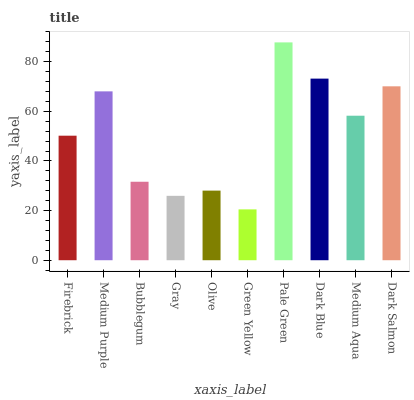Is Green Yellow the minimum?
Answer yes or no. Yes. Is Pale Green the maximum?
Answer yes or no. Yes. Is Medium Purple the minimum?
Answer yes or no. No. Is Medium Purple the maximum?
Answer yes or no. No. Is Medium Purple greater than Firebrick?
Answer yes or no. Yes. Is Firebrick less than Medium Purple?
Answer yes or no. Yes. Is Firebrick greater than Medium Purple?
Answer yes or no. No. Is Medium Purple less than Firebrick?
Answer yes or no. No. Is Medium Aqua the high median?
Answer yes or no. Yes. Is Firebrick the low median?
Answer yes or no. Yes. Is Gray the high median?
Answer yes or no. No. Is Pale Green the low median?
Answer yes or no. No. 